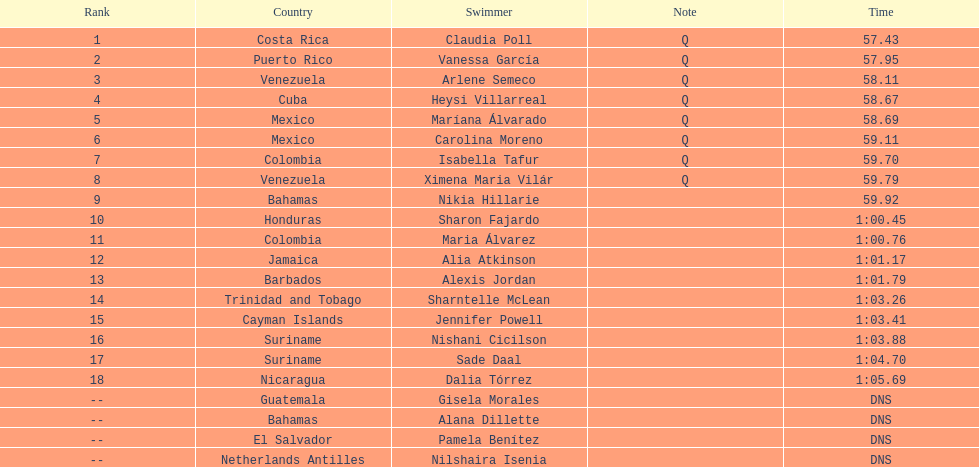Who were the swimmers at the 2006 central american and caribbean games - women's 100 metre freestyle? Claudia Poll, Vanessa García, Arlene Semeco, Heysi Villarreal, Maríana Álvarado, Carolina Moreno, Isabella Tafur, Ximena Maria Vilár, Nikia Hillarie, Sharon Fajardo, Maria Álvarez, Alia Atkinson, Alexis Jordan, Sharntelle McLean, Jennifer Powell, Nishani Cicilson, Sade Daal, Dalia Tórrez, Gisela Morales, Alana Dillette, Pamela Benítez, Nilshaira Isenia. Of these which were from cuba? Heysi Villarreal. 